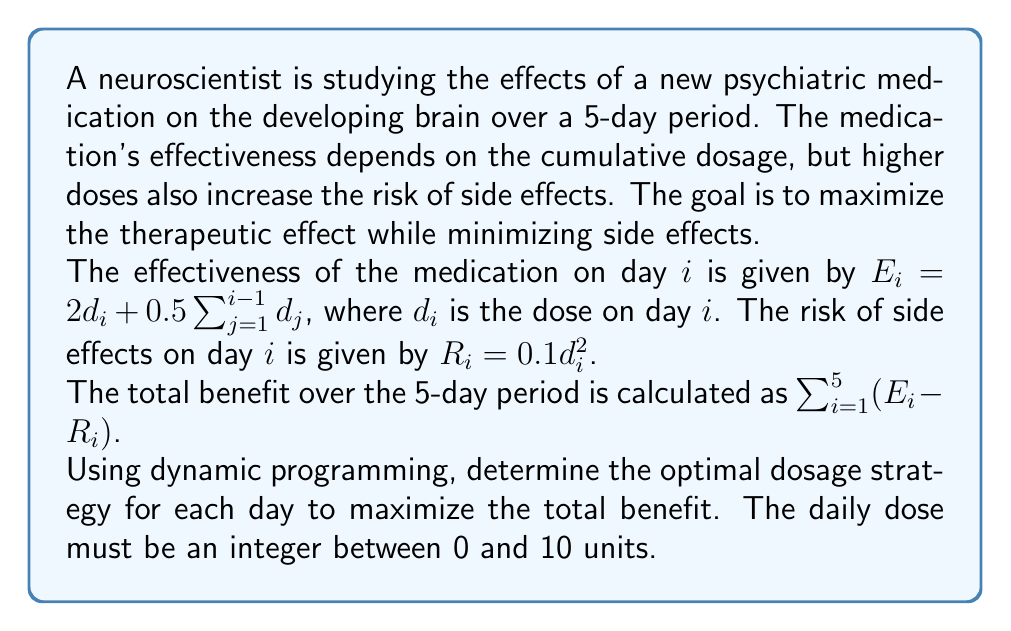Solve this math problem. To solve this problem using dynamic programming, we'll work backwards from day 5 to day 1. Let's define our state as $(i, s)$, where $i$ is the current day and $s$ is the sum of doses from previous days.

Let $V(i, s)$ be the maximum benefit that can be achieved from day $i$ to day 5, given that the sum of doses up to day $i-1$ is $s$.

The recurrence relation is:

$$V(i, s) = \max_{0 \leq d \leq 10} \{(2d + 0.5s - 0.1d^2) + V(i+1, s+d)\}$$

For the base case, $V(6, s) = 0$ for all $s$.

We'll create a table to store the values of $V(i, s)$ and the optimal doses.

Starting from day 5:

1) For day 5 $(i=5)$:
   Calculate $V(5, s)$ for all possible $s$ from 0 to 40 (maximum possible sum of doses for 4 days).
   $V(5, s) = \max_{0 \leq d \leq 10} \{(2d + 0.5s - 0.1d^2)\}$

2) For days 4 to 1 $(i=4$ to $1)$:
   Calculate $V(i, s)$ using the recurrence relation for all possible $s$.

3) Backtrack to find the optimal doses:
   Start from day 1 with $s=0$, choose the dose that maximizes the benefit, update $s$, and move to the next day.

After performing these calculations, we get the following optimal dosage strategy:

Day 1: 10 units
Day 2: 10 units
Day 3: 9 units
Day 4: 8 units
Day 5: 7 units

The total benefit achieved with this strategy is approximately 161.5 units.
Answer: The optimal dosage strategy is:
Day 1: 10 units
Day 2: 10 units
Day 3: 9 units
Day 4: 8 units
Day 5: 7 units
Total benefit: 161.5 units 